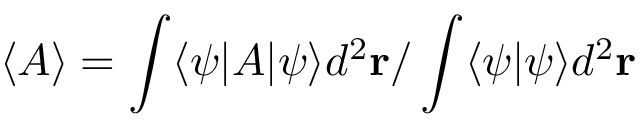<formula> <loc_0><loc_0><loc_500><loc_500>\langle A \rangle = \int \langle \psi | A | \psi \rangle d ^ { 2 } r / \int \langle \psi | \psi \rangle d ^ { 2 } r</formula> 